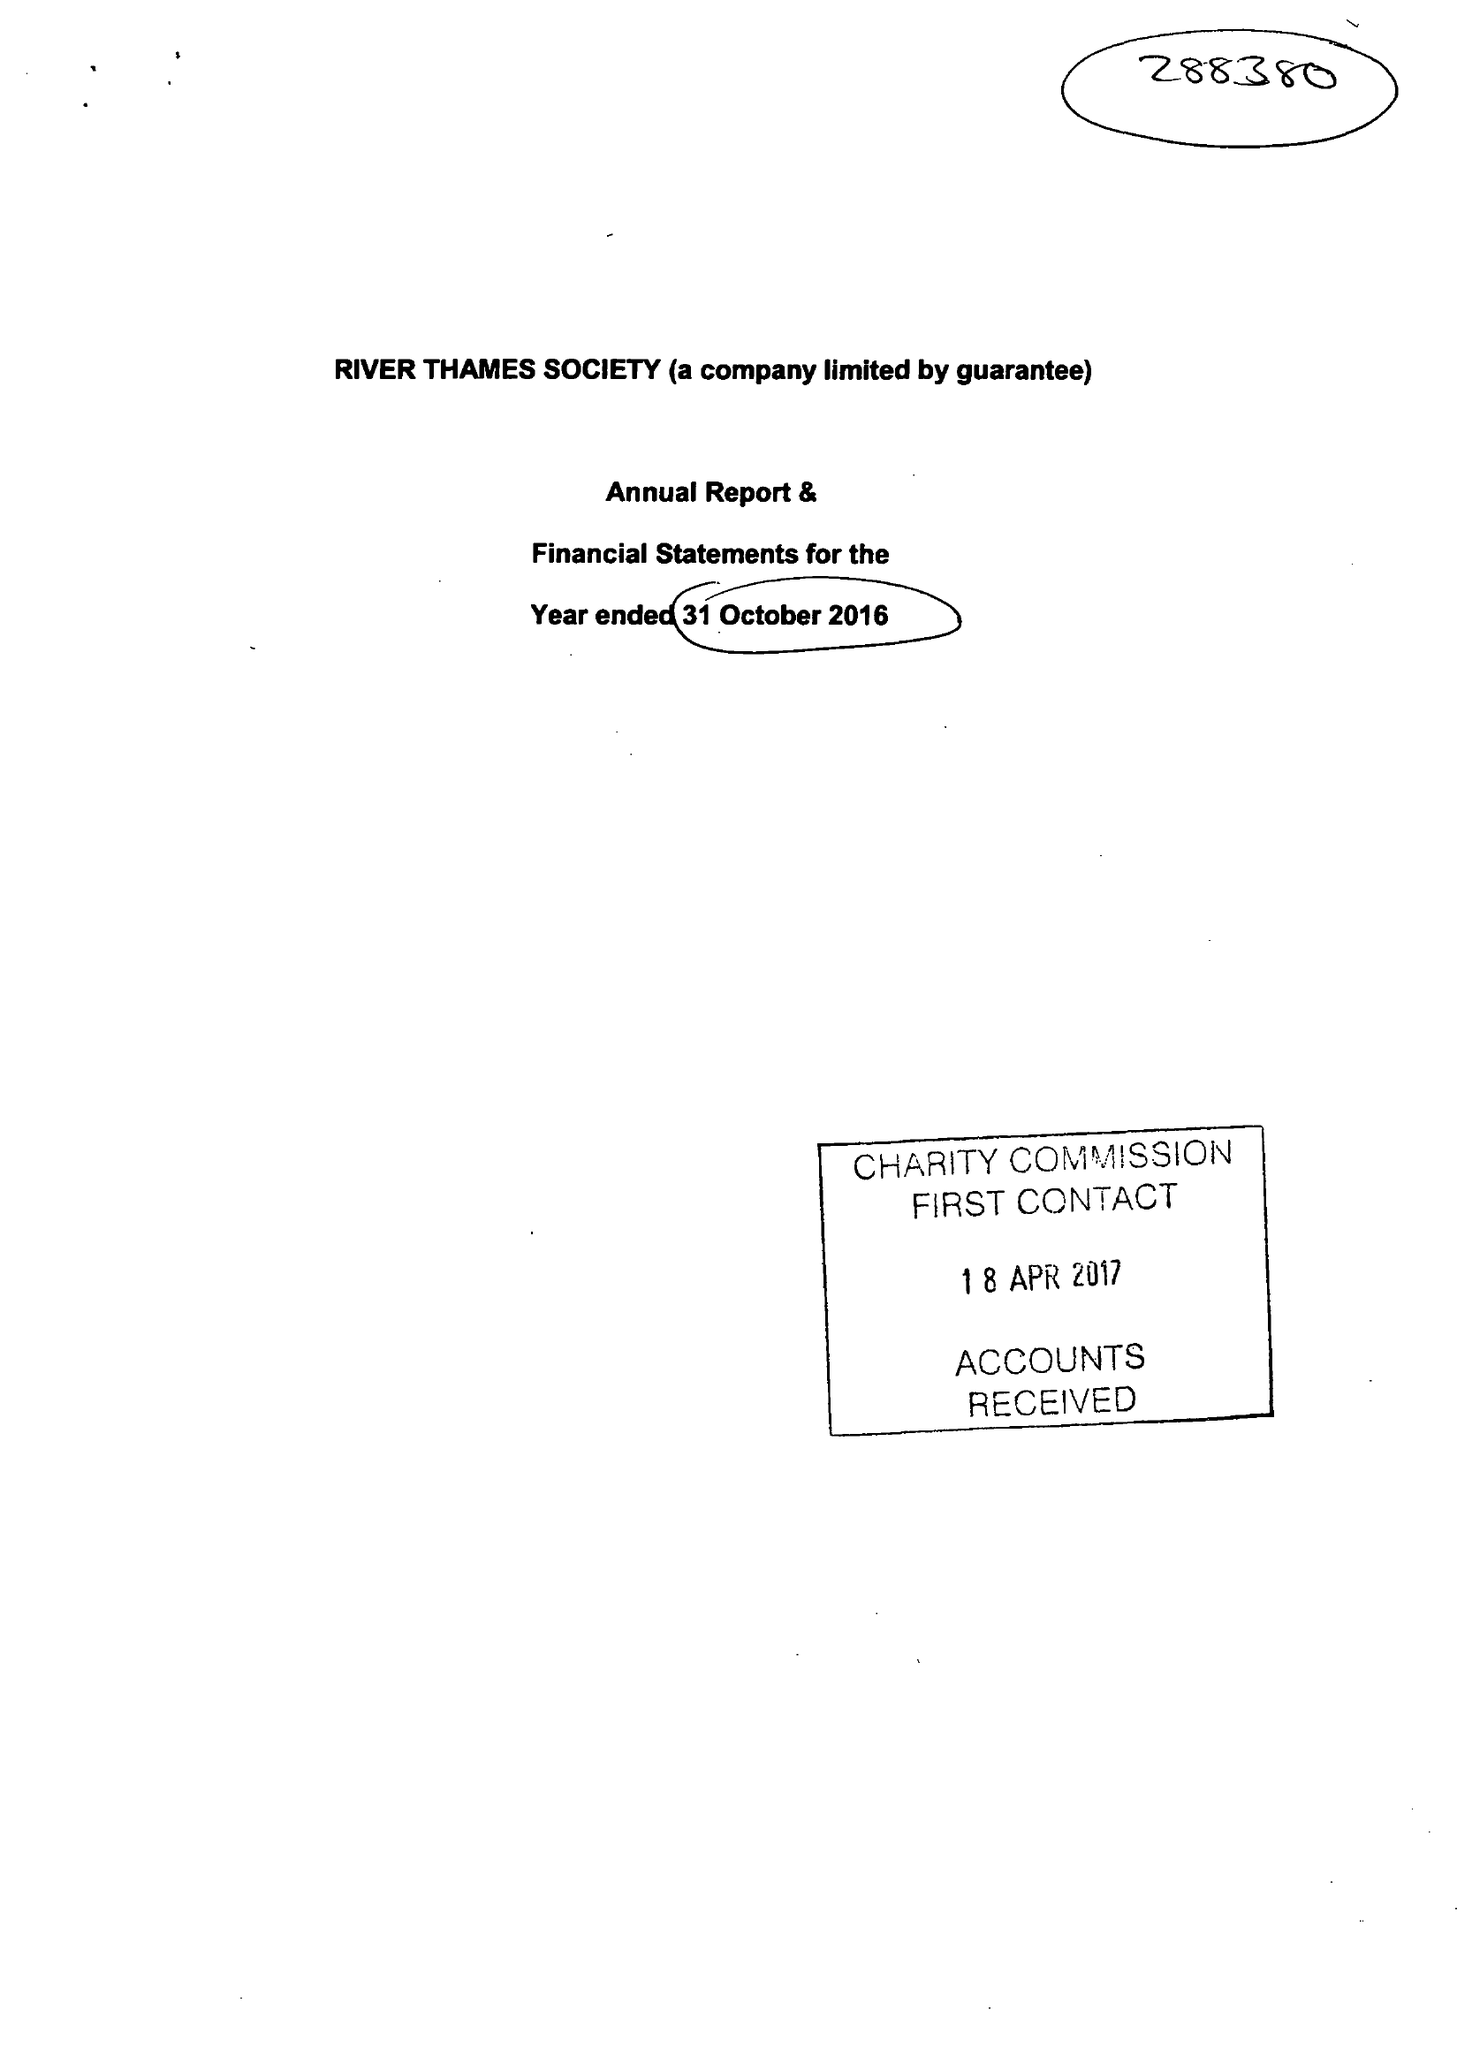What is the value for the spending_annually_in_british_pounds?
Answer the question using a single word or phrase. 33646.00 